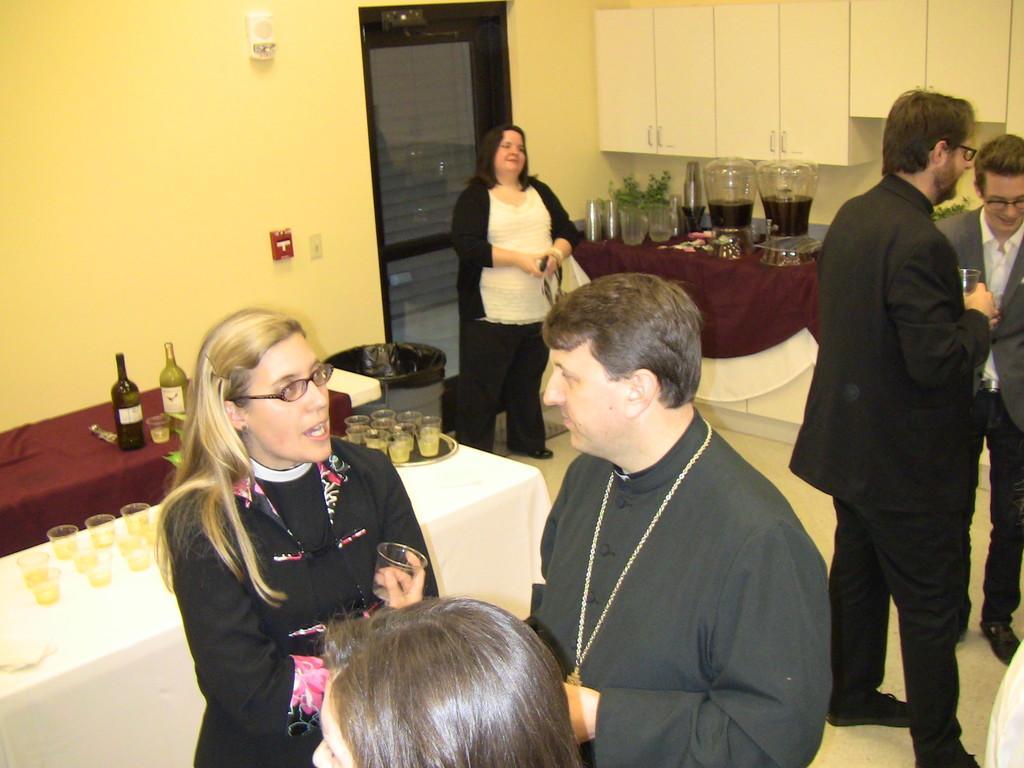Please provide a concise description of this image. In this picture there is a man who is wearing black dress, beside him there is a woman who is wearing spectacle and black dress. Back side of her we can see the table. On the table we can see wine glasses, tray, bottles and other objects. There is a woman who is standing near to the door and dustbin. On the right there is a man who is wearing suit, spectacle, trouser and he is standing near the man who is wearing spectacle, blazer and trouser. In the background there is a table. On the table we can see cloth, glasses, plans buckets and bottles. 